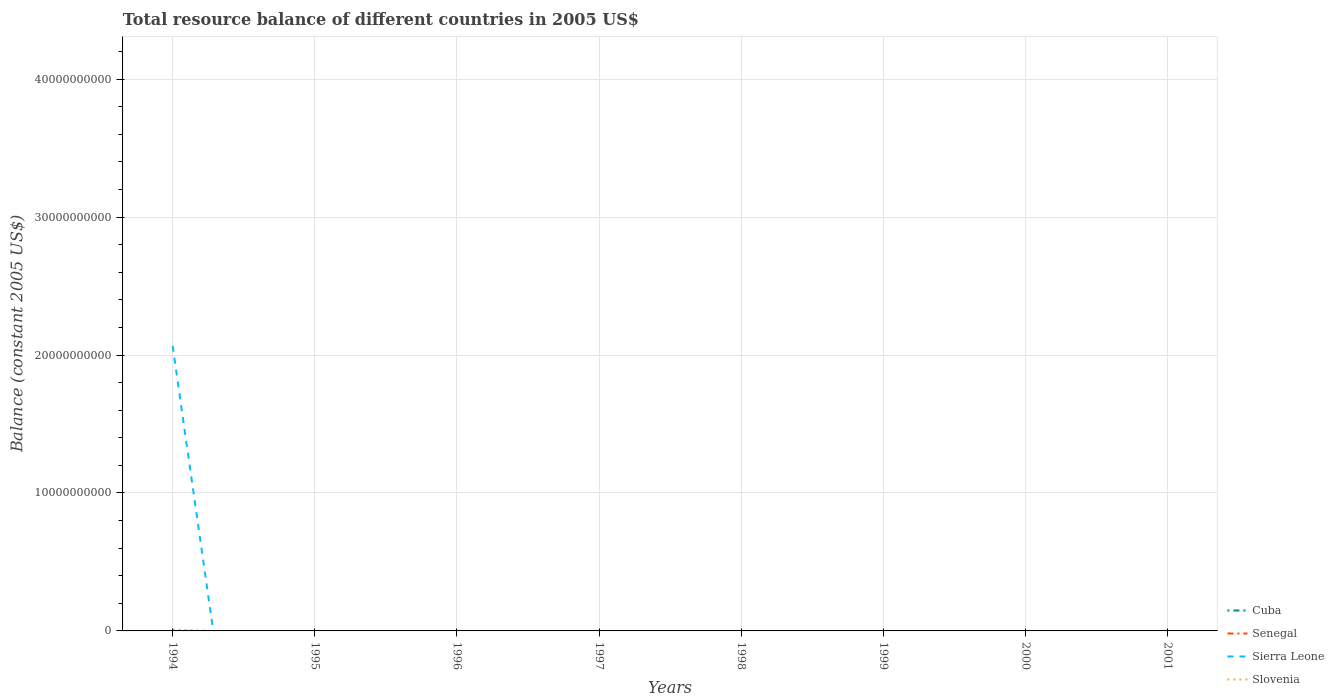How many different coloured lines are there?
Make the answer very short. 2. Is the number of lines equal to the number of legend labels?
Give a very brief answer. No. What is the difference between the highest and the second highest total resource balance in Slovenia?
Give a very brief answer. 1.01e+08. How many lines are there?
Provide a succinct answer. 2. What is the difference between two consecutive major ticks on the Y-axis?
Give a very brief answer. 1.00e+1. Are the values on the major ticks of Y-axis written in scientific E-notation?
Your answer should be compact. No. Does the graph contain any zero values?
Keep it short and to the point. Yes. What is the title of the graph?
Give a very brief answer. Total resource balance of different countries in 2005 US$. What is the label or title of the X-axis?
Give a very brief answer. Years. What is the label or title of the Y-axis?
Provide a succinct answer. Balance (constant 2005 US$). What is the Balance (constant 2005 US$) in Cuba in 1994?
Your answer should be very brief. 0. What is the Balance (constant 2005 US$) of Sierra Leone in 1994?
Make the answer very short. 2.07e+1. What is the Balance (constant 2005 US$) of Slovenia in 1994?
Keep it short and to the point. 1.01e+08. What is the Balance (constant 2005 US$) of Sierra Leone in 1997?
Ensure brevity in your answer.  0. What is the Balance (constant 2005 US$) in Slovenia in 1997?
Offer a very short reply. 0. What is the Balance (constant 2005 US$) in Cuba in 1998?
Offer a terse response. 0. What is the Balance (constant 2005 US$) in Sierra Leone in 1998?
Keep it short and to the point. 0. What is the Balance (constant 2005 US$) in Cuba in 2000?
Provide a short and direct response. 0. What is the Balance (constant 2005 US$) of Sierra Leone in 2000?
Make the answer very short. 0. What is the Balance (constant 2005 US$) of Slovenia in 2000?
Offer a very short reply. 0. What is the Balance (constant 2005 US$) of Sierra Leone in 2001?
Provide a short and direct response. 0. What is the Balance (constant 2005 US$) in Slovenia in 2001?
Offer a very short reply. 0. Across all years, what is the maximum Balance (constant 2005 US$) of Sierra Leone?
Ensure brevity in your answer.  2.07e+1. Across all years, what is the maximum Balance (constant 2005 US$) in Slovenia?
Ensure brevity in your answer.  1.01e+08. Across all years, what is the minimum Balance (constant 2005 US$) in Sierra Leone?
Provide a succinct answer. 0. What is the total Balance (constant 2005 US$) in Sierra Leone in the graph?
Your response must be concise. 2.07e+1. What is the total Balance (constant 2005 US$) of Slovenia in the graph?
Your answer should be very brief. 1.01e+08. What is the average Balance (constant 2005 US$) of Cuba per year?
Your answer should be compact. 0. What is the average Balance (constant 2005 US$) of Senegal per year?
Ensure brevity in your answer.  0. What is the average Balance (constant 2005 US$) of Sierra Leone per year?
Your response must be concise. 2.58e+09. What is the average Balance (constant 2005 US$) of Slovenia per year?
Your answer should be compact. 1.27e+07. In the year 1994, what is the difference between the Balance (constant 2005 US$) of Sierra Leone and Balance (constant 2005 US$) of Slovenia?
Give a very brief answer. 2.06e+1. What is the difference between the highest and the lowest Balance (constant 2005 US$) in Sierra Leone?
Your answer should be very brief. 2.07e+1. What is the difference between the highest and the lowest Balance (constant 2005 US$) of Slovenia?
Keep it short and to the point. 1.01e+08. 